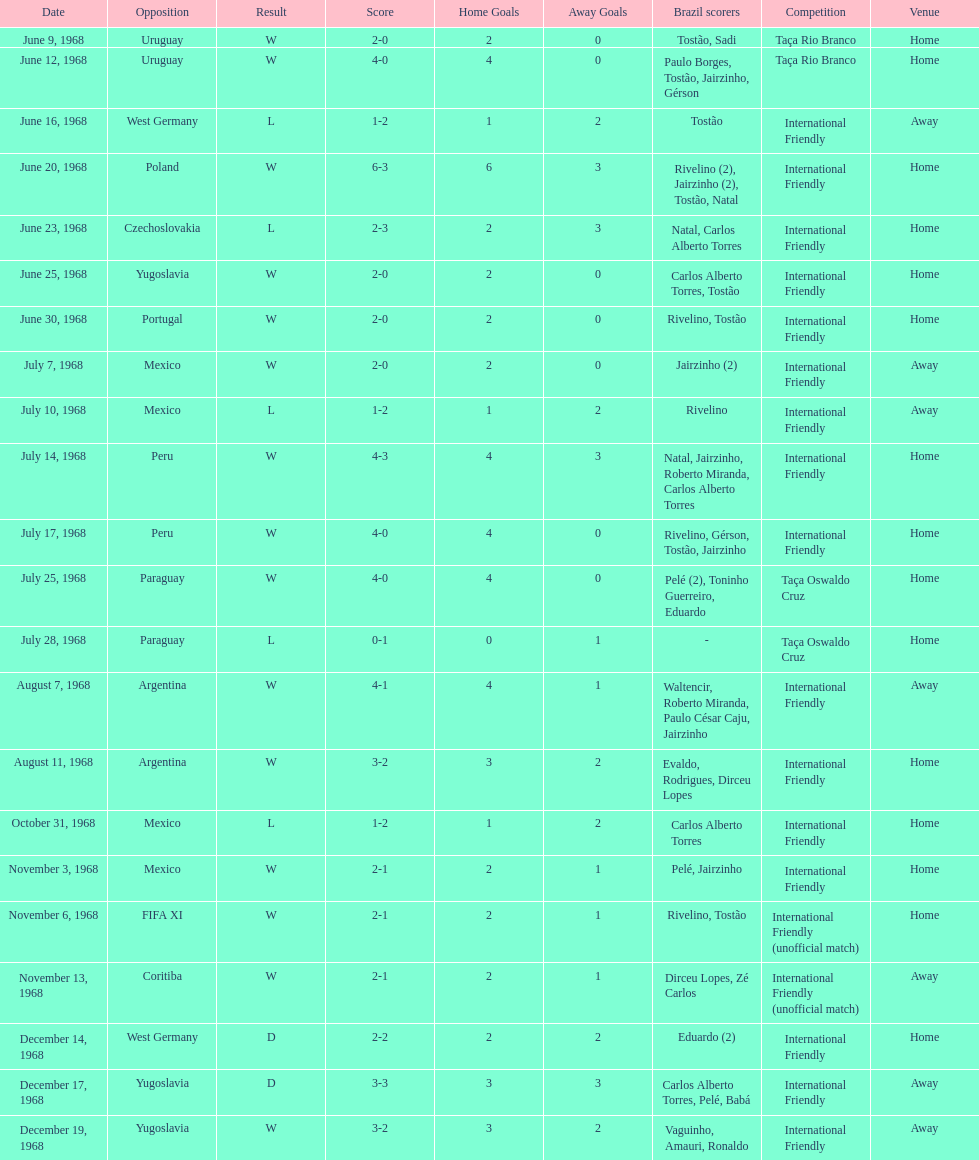What's the total number of ties? 2. 